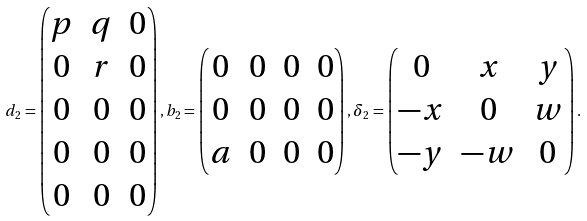Convert formula to latex. <formula><loc_0><loc_0><loc_500><loc_500>d _ { 2 } = \begin{pmatrix} p & q & 0 \\ 0 & r & 0 \\ 0 & 0 & 0 \\ 0 & 0 & 0 \\ 0 & 0 & 0 \end{pmatrix} , b _ { 2 } = \begin{pmatrix} 0 & 0 & 0 & 0 \\ 0 & 0 & 0 & 0 \\ a & 0 & 0 & 0 \end{pmatrix} , \delta _ { 2 } = \begin{pmatrix} 0 & x & y \\ - x & 0 & w \\ - y & - w & 0 \end{pmatrix} .</formula> 